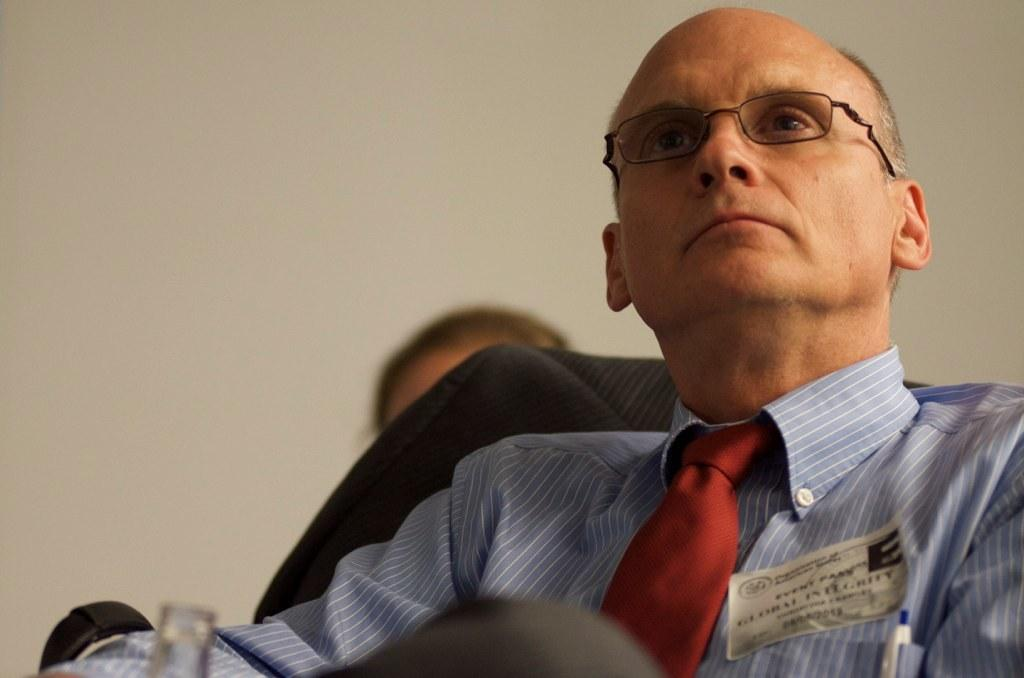What can be seen in the background of the image? There is a wall in the image. Who is present in the image? There is a man in the image. What is the man wearing on his upper body? The man is wearing a blue shirt and a red tie. What is the man's position in the image? The man is sitting on a chair. Can you see a snake slithering on the wall in the image? There is no snake present in the image; only a wall and a man sitting on a chair are visible. What does the man believe about the existence of quills in the image? There is no mention of quills or beliefs in the image, so it is not possible to answer that question. 